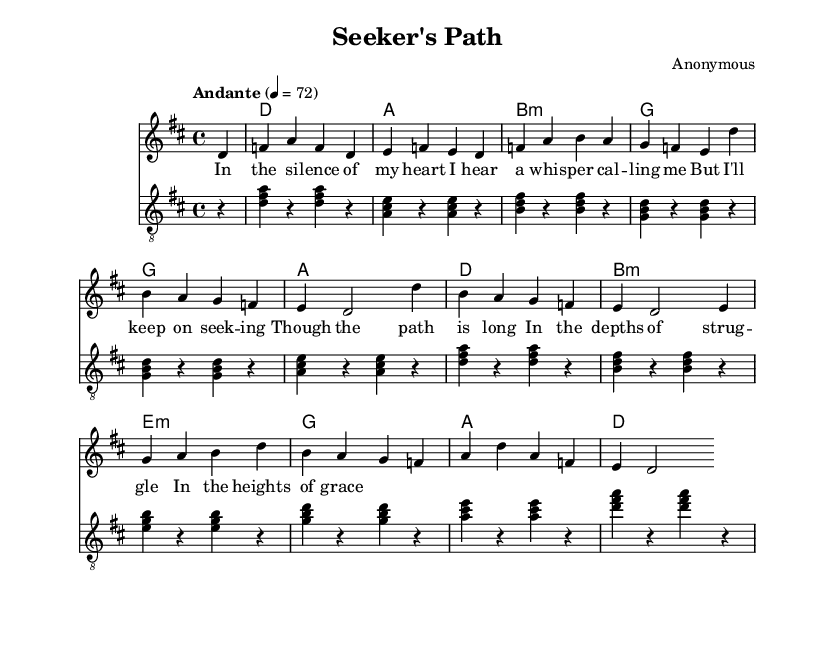What is the key signature of this music? The key signature is D major, which has two sharps (F# and C#). This is identified by looking at the key signature section in the music notation.
Answer: D major What is the time signature of this piece? The time signature is 4/4, which indicates that there are four beats in each measure and the quarter note gets the beat. This is seen at the beginning of the music piece.
Answer: 4/4 What is the tempo marking of the piece? The tempo is indicated as "Andante" with a metronome marking of 72, which provides a moderate pace for the music. This is stated in the tempo section of the music.
Answer: Andante, 72 How many measures are in the voice part? The voice part contains 8 measures, as counted from the beginning of the staff to the end of the last line of lyrics. Each measure is clearly defined by vertical lines in the music notation.
Answer: 8 What chords are used in the chorus of the song? The chords used in the chorus are D, A, B minor, G, and E minor. These chords are noted in the chord mode section beneath the lyrics, indicating the harmonic support for the melody.
Answer: D, A, B minor, G, E minor What is the primary theme expressed in the lyrics? The primary theme expressed in the lyrics is a personal spiritual journey of seeking, struggle, and grace, as evident from lines that indicate introspection and perseverance. The lyrics convey deep emotional and spiritual sentiments reflective of a contemplative journey.
Answer: Seeking and spiritual journey 